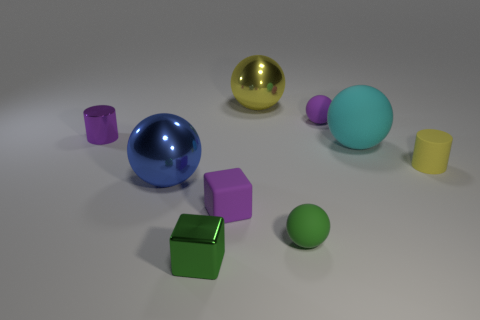Subtract all large blue metal spheres. How many spheres are left? 4 Subtract 1 cubes. How many cubes are left? 1 Subtract all green spheres. How many spheres are left? 4 Subtract all cylinders. How many objects are left? 7 Add 8 purple rubber things. How many purple rubber things exist? 10 Subtract 1 purple cubes. How many objects are left? 8 Subtract all red cylinders. Subtract all gray cubes. How many cylinders are left? 2 Subtract all yellow spheres. Subtract all yellow things. How many objects are left? 6 Add 6 large blue objects. How many large blue objects are left? 7 